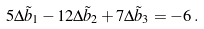Convert formula to latex. <formula><loc_0><loc_0><loc_500><loc_500>5 \Delta \tilde { b } _ { 1 } - 1 2 \Delta \tilde { b } _ { 2 } + 7 \Delta \tilde { b } _ { 3 } = - 6 \, .</formula> 